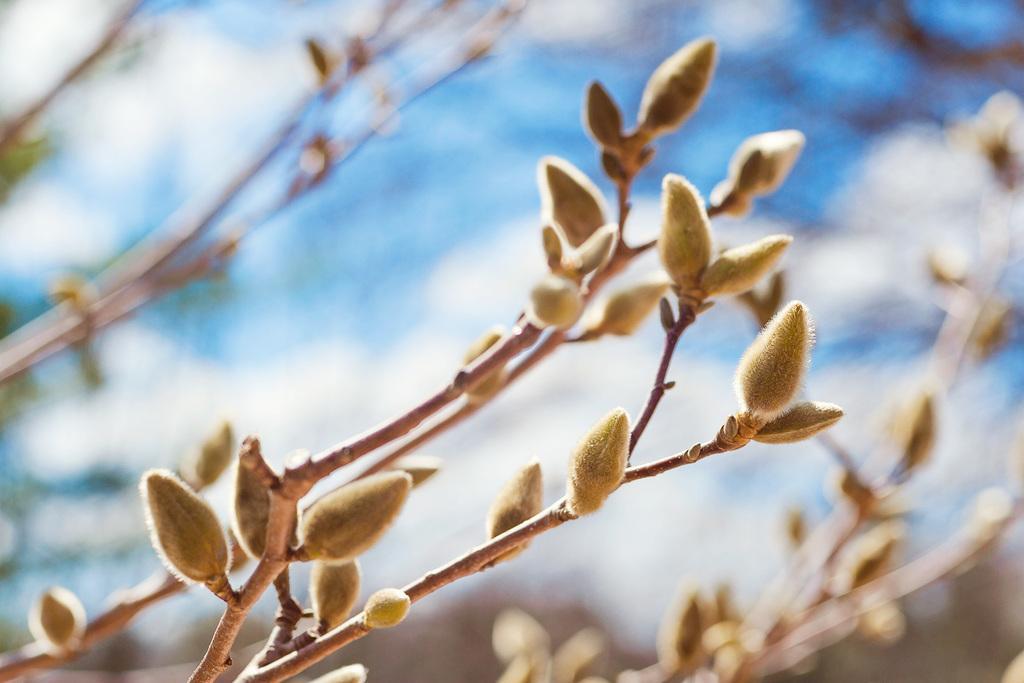Describe this image in one or two sentences. In this image I can see a plant and I can also see few buds which are in cream color. 